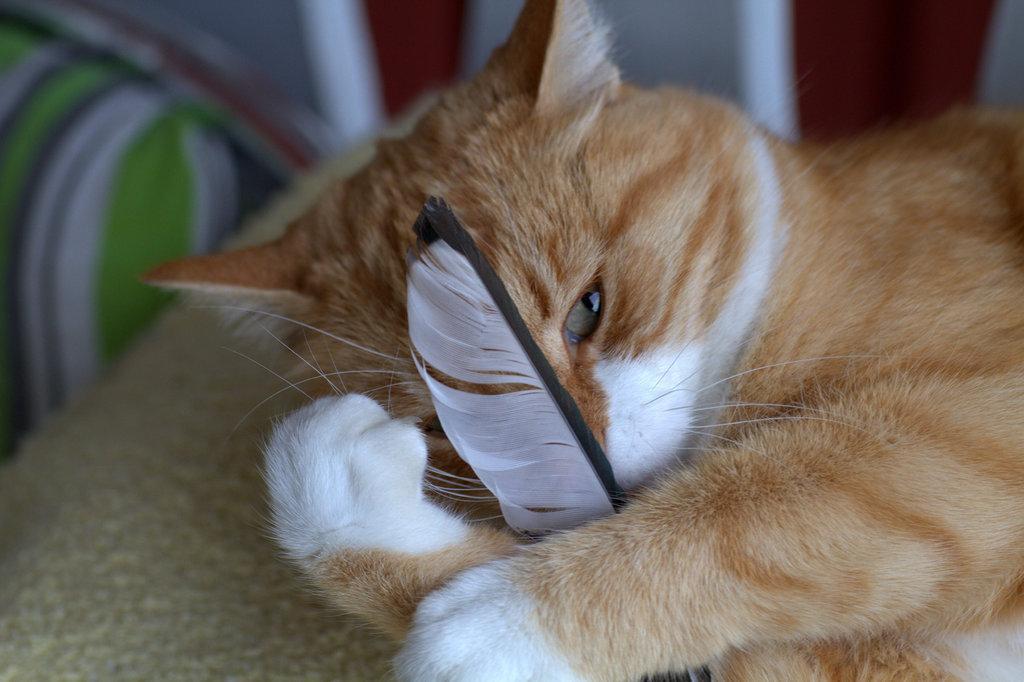Describe this image in one or two sentences. In this image we can see there is a cat lay and holding some object. 